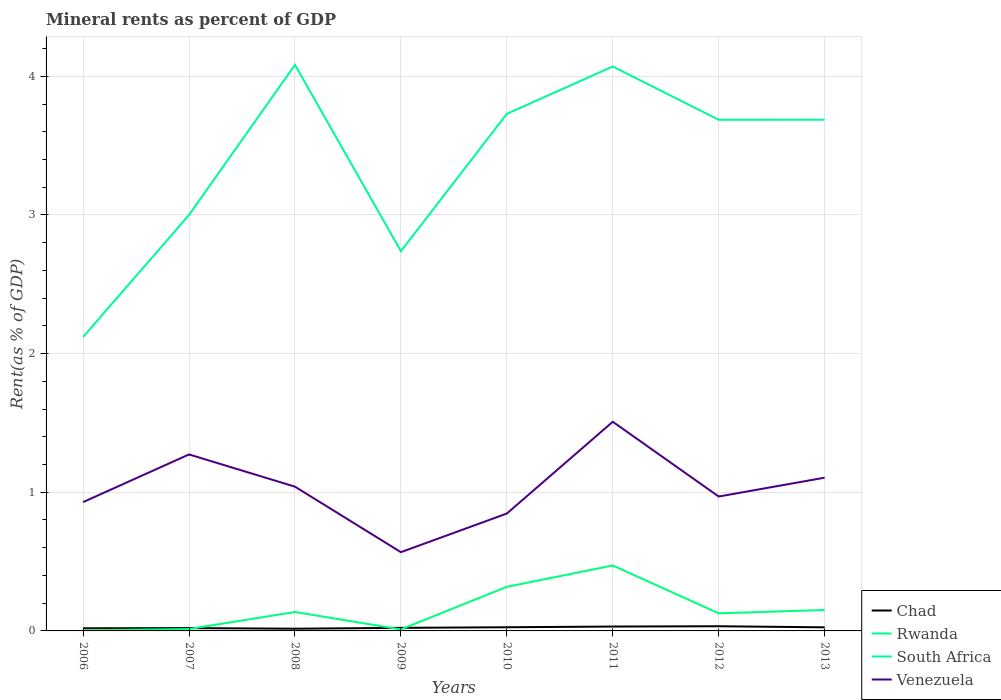Does the line corresponding to Rwanda intersect with the line corresponding to Chad?
Provide a short and direct response. Yes. Across all years, what is the maximum mineral rent in South Africa?
Offer a terse response. 2.12. What is the total mineral rent in Rwanda in the graph?
Ensure brevity in your answer.  -0.12. What is the difference between the highest and the second highest mineral rent in Chad?
Make the answer very short. 0.02. How many lines are there?
Give a very brief answer. 4. How many years are there in the graph?
Make the answer very short. 8. Are the values on the major ticks of Y-axis written in scientific E-notation?
Your response must be concise. No. What is the title of the graph?
Your answer should be very brief. Mineral rents as percent of GDP. What is the label or title of the X-axis?
Offer a terse response. Years. What is the label or title of the Y-axis?
Provide a short and direct response. Rent(as % of GDP). What is the Rent(as % of GDP) in Chad in 2006?
Provide a succinct answer. 0.02. What is the Rent(as % of GDP) of Rwanda in 2006?
Provide a succinct answer. 0. What is the Rent(as % of GDP) in South Africa in 2006?
Your answer should be compact. 2.12. What is the Rent(as % of GDP) of Venezuela in 2006?
Make the answer very short. 0.93. What is the Rent(as % of GDP) in Chad in 2007?
Keep it short and to the point. 0.02. What is the Rent(as % of GDP) in Rwanda in 2007?
Offer a terse response. 0.01. What is the Rent(as % of GDP) in South Africa in 2007?
Ensure brevity in your answer.  3. What is the Rent(as % of GDP) in Venezuela in 2007?
Keep it short and to the point. 1.27. What is the Rent(as % of GDP) of Chad in 2008?
Your response must be concise. 0.02. What is the Rent(as % of GDP) in Rwanda in 2008?
Offer a very short reply. 0.14. What is the Rent(as % of GDP) in South Africa in 2008?
Provide a succinct answer. 4.08. What is the Rent(as % of GDP) in Venezuela in 2008?
Your answer should be compact. 1.04. What is the Rent(as % of GDP) in Chad in 2009?
Keep it short and to the point. 0.02. What is the Rent(as % of GDP) of Rwanda in 2009?
Offer a very short reply. 0.01. What is the Rent(as % of GDP) of South Africa in 2009?
Offer a very short reply. 2.74. What is the Rent(as % of GDP) in Venezuela in 2009?
Offer a terse response. 0.57. What is the Rent(as % of GDP) in Chad in 2010?
Provide a short and direct response. 0.03. What is the Rent(as % of GDP) in Rwanda in 2010?
Your answer should be very brief. 0.32. What is the Rent(as % of GDP) of South Africa in 2010?
Your answer should be very brief. 3.73. What is the Rent(as % of GDP) in Venezuela in 2010?
Make the answer very short. 0.85. What is the Rent(as % of GDP) of Chad in 2011?
Your answer should be compact. 0.03. What is the Rent(as % of GDP) in Rwanda in 2011?
Your answer should be compact. 0.47. What is the Rent(as % of GDP) of South Africa in 2011?
Your response must be concise. 4.07. What is the Rent(as % of GDP) in Venezuela in 2011?
Your response must be concise. 1.51. What is the Rent(as % of GDP) of Chad in 2012?
Offer a terse response. 0.03. What is the Rent(as % of GDP) in Rwanda in 2012?
Provide a short and direct response. 0.13. What is the Rent(as % of GDP) of South Africa in 2012?
Your response must be concise. 3.69. What is the Rent(as % of GDP) in Venezuela in 2012?
Provide a succinct answer. 0.97. What is the Rent(as % of GDP) of Chad in 2013?
Your response must be concise. 0.03. What is the Rent(as % of GDP) in Rwanda in 2013?
Your answer should be very brief. 0.15. What is the Rent(as % of GDP) in South Africa in 2013?
Make the answer very short. 3.69. What is the Rent(as % of GDP) of Venezuela in 2013?
Offer a very short reply. 1.11. Across all years, what is the maximum Rent(as % of GDP) of Chad?
Your answer should be very brief. 0.03. Across all years, what is the maximum Rent(as % of GDP) in Rwanda?
Make the answer very short. 0.47. Across all years, what is the maximum Rent(as % of GDP) in South Africa?
Offer a terse response. 4.08. Across all years, what is the maximum Rent(as % of GDP) in Venezuela?
Your answer should be compact. 1.51. Across all years, what is the minimum Rent(as % of GDP) in Chad?
Keep it short and to the point. 0.02. Across all years, what is the minimum Rent(as % of GDP) of Rwanda?
Provide a succinct answer. 0. Across all years, what is the minimum Rent(as % of GDP) of South Africa?
Offer a very short reply. 2.12. Across all years, what is the minimum Rent(as % of GDP) of Venezuela?
Provide a short and direct response. 0.57. What is the total Rent(as % of GDP) in Chad in the graph?
Your answer should be very brief. 0.2. What is the total Rent(as % of GDP) of Rwanda in the graph?
Your answer should be very brief. 1.23. What is the total Rent(as % of GDP) in South Africa in the graph?
Ensure brevity in your answer.  27.11. What is the total Rent(as % of GDP) of Venezuela in the graph?
Provide a succinct answer. 8.24. What is the difference between the Rent(as % of GDP) of Chad in 2006 and that in 2007?
Your response must be concise. -0. What is the difference between the Rent(as % of GDP) of Rwanda in 2006 and that in 2007?
Provide a succinct answer. -0.01. What is the difference between the Rent(as % of GDP) in South Africa in 2006 and that in 2007?
Give a very brief answer. -0.88. What is the difference between the Rent(as % of GDP) in Venezuela in 2006 and that in 2007?
Provide a short and direct response. -0.34. What is the difference between the Rent(as % of GDP) in Chad in 2006 and that in 2008?
Keep it short and to the point. 0. What is the difference between the Rent(as % of GDP) in Rwanda in 2006 and that in 2008?
Your response must be concise. -0.13. What is the difference between the Rent(as % of GDP) in South Africa in 2006 and that in 2008?
Offer a terse response. -1.96. What is the difference between the Rent(as % of GDP) of Venezuela in 2006 and that in 2008?
Provide a short and direct response. -0.11. What is the difference between the Rent(as % of GDP) of Chad in 2006 and that in 2009?
Your response must be concise. -0. What is the difference between the Rent(as % of GDP) in Rwanda in 2006 and that in 2009?
Your answer should be compact. -0.01. What is the difference between the Rent(as % of GDP) of South Africa in 2006 and that in 2009?
Make the answer very short. -0.62. What is the difference between the Rent(as % of GDP) of Venezuela in 2006 and that in 2009?
Your response must be concise. 0.36. What is the difference between the Rent(as % of GDP) in Chad in 2006 and that in 2010?
Offer a very short reply. -0.01. What is the difference between the Rent(as % of GDP) of Rwanda in 2006 and that in 2010?
Offer a very short reply. -0.31. What is the difference between the Rent(as % of GDP) in South Africa in 2006 and that in 2010?
Make the answer very short. -1.61. What is the difference between the Rent(as % of GDP) in Venezuela in 2006 and that in 2010?
Your answer should be very brief. 0.08. What is the difference between the Rent(as % of GDP) of Chad in 2006 and that in 2011?
Keep it short and to the point. -0.01. What is the difference between the Rent(as % of GDP) of Rwanda in 2006 and that in 2011?
Provide a succinct answer. -0.47. What is the difference between the Rent(as % of GDP) in South Africa in 2006 and that in 2011?
Your answer should be compact. -1.95. What is the difference between the Rent(as % of GDP) in Venezuela in 2006 and that in 2011?
Ensure brevity in your answer.  -0.58. What is the difference between the Rent(as % of GDP) in Chad in 2006 and that in 2012?
Provide a succinct answer. -0.01. What is the difference between the Rent(as % of GDP) of Rwanda in 2006 and that in 2012?
Ensure brevity in your answer.  -0.12. What is the difference between the Rent(as % of GDP) in South Africa in 2006 and that in 2012?
Your answer should be compact. -1.57. What is the difference between the Rent(as % of GDP) in Venezuela in 2006 and that in 2012?
Offer a very short reply. -0.04. What is the difference between the Rent(as % of GDP) in Chad in 2006 and that in 2013?
Provide a succinct answer. -0.01. What is the difference between the Rent(as % of GDP) in Rwanda in 2006 and that in 2013?
Your answer should be compact. -0.15. What is the difference between the Rent(as % of GDP) of South Africa in 2006 and that in 2013?
Your answer should be compact. -1.57. What is the difference between the Rent(as % of GDP) of Venezuela in 2006 and that in 2013?
Offer a terse response. -0.18. What is the difference between the Rent(as % of GDP) in Chad in 2007 and that in 2008?
Ensure brevity in your answer.  0. What is the difference between the Rent(as % of GDP) of Rwanda in 2007 and that in 2008?
Your response must be concise. -0.12. What is the difference between the Rent(as % of GDP) in South Africa in 2007 and that in 2008?
Your response must be concise. -1.08. What is the difference between the Rent(as % of GDP) in Venezuela in 2007 and that in 2008?
Offer a very short reply. 0.23. What is the difference between the Rent(as % of GDP) in Chad in 2007 and that in 2009?
Your response must be concise. -0. What is the difference between the Rent(as % of GDP) in Rwanda in 2007 and that in 2009?
Make the answer very short. 0. What is the difference between the Rent(as % of GDP) in South Africa in 2007 and that in 2009?
Your answer should be very brief. 0.26. What is the difference between the Rent(as % of GDP) in Venezuela in 2007 and that in 2009?
Provide a short and direct response. 0.7. What is the difference between the Rent(as % of GDP) in Chad in 2007 and that in 2010?
Make the answer very short. -0.01. What is the difference between the Rent(as % of GDP) of Rwanda in 2007 and that in 2010?
Offer a terse response. -0.3. What is the difference between the Rent(as % of GDP) in South Africa in 2007 and that in 2010?
Offer a very short reply. -0.73. What is the difference between the Rent(as % of GDP) in Venezuela in 2007 and that in 2010?
Your answer should be compact. 0.43. What is the difference between the Rent(as % of GDP) in Chad in 2007 and that in 2011?
Provide a succinct answer. -0.01. What is the difference between the Rent(as % of GDP) in Rwanda in 2007 and that in 2011?
Your answer should be compact. -0.46. What is the difference between the Rent(as % of GDP) of South Africa in 2007 and that in 2011?
Keep it short and to the point. -1.07. What is the difference between the Rent(as % of GDP) of Venezuela in 2007 and that in 2011?
Your response must be concise. -0.24. What is the difference between the Rent(as % of GDP) of Chad in 2007 and that in 2012?
Your response must be concise. -0.01. What is the difference between the Rent(as % of GDP) in Rwanda in 2007 and that in 2012?
Your response must be concise. -0.11. What is the difference between the Rent(as % of GDP) in South Africa in 2007 and that in 2012?
Your response must be concise. -0.69. What is the difference between the Rent(as % of GDP) in Venezuela in 2007 and that in 2012?
Keep it short and to the point. 0.3. What is the difference between the Rent(as % of GDP) of Chad in 2007 and that in 2013?
Offer a very short reply. -0.01. What is the difference between the Rent(as % of GDP) of Rwanda in 2007 and that in 2013?
Provide a short and direct response. -0.14. What is the difference between the Rent(as % of GDP) in South Africa in 2007 and that in 2013?
Your response must be concise. -0.69. What is the difference between the Rent(as % of GDP) in Venezuela in 2007 and that in 2013?
Offer a very short reply. 0.17. What is the difference between the Rent(as % of GDP) of Chad in 2008 and that in 2009?
Provide a succinct answer. -0.01. What is the difference between the Rent(as % of GDP) in Rwanda in 2008 and that in 2009?
Offer a terse response. 0.13. What is the difference between the Rent(as % of GDP) in South Africa in 2008 and that in 2009?
Keep it short and to the point. 1.34. What is the difference between the Rent(as % of GDP) in Venezuela in 2008 and that in 2009?
Provide a succinct answer. 0.47. What is the difference between the Rent(as % of GDP) of Chad in 2008 and that in 2010?
Your response must be concise. -0.01. What is the difference between the Rent(as % of GDP) of Rwanda in 2008 and that in 2010?
Provide a succinct answer. -0.18. What is the difference between the Rent(as % of GDP) in South Africa in 2008 and that in 2010?
Provide a short and direct response. 0.35. What is the difference between the Rent(as % of GDP) of Venezuela in 2008 and that in 2010?
Ensure brevity in your answer.  0.19. What is the difference between the Rent(as % of GDP) in Chad in 2008 and that in 2011?
Your answer should be compact. -0.02. What is the difference between the Rent(as % of GDP) of Rwanda in 2008 and that in 2011?
Your answer should be very brief. -0.34. What is the difference between the Rent(as % of GDP) of South Africa in 2008 and that in 2011?
Provide a short and direct response. 0.01. What is the difference between the Rent(as % of GDP) of Venezuela in 2008 and that in 2011?
Offer a terse response. -0.47. What is the difference between the Rent(as % of GDP) of Chad in 2008 and that in 2012?
Your answer should be compact. -0.02. What is the difference between the Rent(as % of GDP) in Rwanda in 2008 and that in 2012?
Make the answer very short. 0.01. What is the difference between the Rent(as % of GDP) of South Africa in 2008 and that in 2012?
Provide a succinct answer. 0.4. What is the difference between the Rent(as % of GDP) in Venezuela in 2008 and that in 2012?
Provide a short and direct response. 0.07. What is the difference between the Rent(as % of GDP) in Chad in 2008 and that in 2013?
Make the answer very short. -0.01. What is the difference between the Rent(as % of GDP) of Rwanda in 2008 and that in 2013?
Your answer should be compact. -0.01. What is the difference between the Rent(as % of GDP) in South Africa in 2008 and that in 2013?
Ensure brevity in your answer.  0.4. What is the difference between the Rent(as % of GDP) of Venezuela in 2008 and that in 2013?
Your answer should be compact. -0.06. What is the difference between the Rent(as % of GDP) of Chad in 2009 and that in 2010?
Make the answer very short. -0. What is the difference between the Rent(as % of GDP) of Rwanda in 2009 and that in 2010?
Your response must be concise. -0.31. What is the difference between the Rent(as % of GDP) in South Africa in 2009 and that in 2010?
Offer a very short reply. -0.99. What is the difference between the Rent(as % of GDP) of Venezuela in 2009 and that in 2010?
Ensure brevity in your answer.  -0.28. What is the difference between the Rent(as % of GDP) of Chad in 2009 and that in 2011?
Provide a succinct answer. -0.01. What is the difference between the Rent(as % of GDP) in Rwanda in 2009 and that in 2011?
Your answer should be compact. -0.46. What is the difference between the Rent(as % of GDP) of South Africa in 2009 and that in 2011?
Make the answer very short. -1.33. What is the difference between the Rent(as % of GDP) of Venezuela in 2009 and that in 2011?
Keep it short and to the point. -0.94. What is the difference between the Rent(as % of GDP) in Chad in 2009 and that in 2012?
Your answer should be very brief. -0.01. What is the difference between the Rent(as % of GDP) in Rwanda in 2009 and that in 2012?
Give a very brief answer. -0.12. What is the difference between the Rent(as % of GDP) of South Africa in 2009 and that in 2012?
Give a very brief answer. -0.95. What is the difference between the Rent(as % of GDP) in Venezuela in 2009 and that in 2012?
Offer a terse response. -0.4. What is the difference between the Rent(as % of GDP) in Chad in 2009 and that in 2013?
Your response must be concise. -0. What is the difference between the Rent(as % of GDP) of Rwanda in 2009 and that in 2013?
Keep it short and to the point. -0.14. What is the difference between the Rent(as % of GDP) of South Africa in 2009 and that in 2013?
Your answer should be very brief. -0.95. What is the difference between the Rent(as % of GDP) of Venezuela in 2009 and that in 2013?
Make the answer very short. -0.54. What is the difference between the Rent(as % of GDP) of Chad in 2010 and that in 2011?
Ensure brevity in your answer.  -0.01. What is the difference between the Rent(as % of GDP) of Rwanda in 2010 and that in 2011?
Your response must be concise. -0.15. What is the difference between the Rent(as % of GDP) in South Africa in 2010 and that in 2011?
Offer a very short reply. -0.34. What is the difference between the Rent(as % of GDP) in Venezuela in 2010 and that in 2011?
Keep it short and to the point. -0.66. What is the difference between the Rent(as % of GDP) of Chad in 2010 and that in 2012?
Give a very brief answer. -0.01. What is the difference between the Rent(as % of GDP) in Rwanda in 2010 and that in 2012?
Your answer should be compact. 0.19. What is the difference between the Rent(as % of GDP) in South Africa in 2010 and that in 2012?
Your answer should be very brief. 0.04. What is the difference between the Rent(as % of GDP) in Venezuela in 2010 and that in 2012?
Your answer should be compact. -0.12. What is the difference between the Rent(as % of GDP) in Chad in 2010 and that in 2013?
Keep it short and to the point. 0. What is the difference between the Rent(as % of GDP) of Rwanda in 2010 and that in 2013?
Offer a terse response. 0.17. What is the difference between the Rent(as % of GDP) of South Africa in 2010 and that in 2013?
Your response must be concise. 0.04. What is the difference between the Rent(as % of GDP) in Venezuela in 2010 and that in 2013?
Ensure brevity in your answer.  -0.26. What is the difference between the Rent(as % of GDP) in Chad in 2011 and that in 2012?
Offer a very short reply. -0. What is the difference between the Rent(as % of GDP) in Rwanda in 2011 and that in 2012?
Provide a short and direct response. 0.34. What is the difference between the Rent(as % of GDP) in South Africa in 2011 and that in 2012?
Your answer should be compact. 0.38. What is the difference between the Rent(as % of GDP) in Venezuela in 2011 and that in 2012?
Your answer should be very brief. 0.54. What is the difference between the Rent(as % of GDP) of Chad in 2011 and that in 2013?
Your answer should be very brief. 0.01. What is the difference between the Rent(as % of GDP) in Rwanda in 2011 and that in 2013?
Your answer should be very brief. 0.32. What is the difference between the Rent(as % of GDP) in South Africa in 2011 and that in 2013?
Your answer should be compact. 0.38. What is the difference between the Rent(as % of GDP) in Venezuela in 2011 and that in 2013?
Provide a short and direct response. 0.4. What is the difference between the Rent(as % of GDP) in Chad in 2012 and that in 2013?
Your answer should be very brief. 0.01. What is the difference between the Rent(as % of GDP) in Rwanda in 2012 and that in 2013?
Your response must be concise. -0.02. What is the difference between the Rent(as % of GDP) of South Africa in 2012 and that in 2013?
Give a very brief answer. -0. What is the difference between the Rent(as % of GDP) of Venezuela in 2012 and that in 2013?
Your response must be concise. -0.14. What is the difference between the Rent(as % of GDP) of Chad in 2006 and the Rent(as % of GDP) of Rwanda in 2007?
Your response must be concise. 0.01. What is the difference between the Rent(as % of GDP) in Chad in 2006 and the Rent(as % of GDP) in South Africa in 2007?
Ensure brevity in your answer.  -2.98. What is the difference between the Rent(as % of GDP) in Chad in 2006 and the Rent(as % of GDP) in Venezuela in 2007?
Provide a succinct answer. -1.25. What is the difference between the Rent(as % of GDP) in Rwanda in 2006 and the Rent(as % of GDP) in South Africa in 2007?
Your response must be concise. -3. What is the difference between the Rent(as % of GDP) in Rwanda in 2006 and the Rent(as % of GDP) in Venezuela in 2007?
Provide a succinct answer. -1.27. What is the difference between the Rent(as % of GDP) of South Africa in 2006 and the Rent(as % of GDP) of Venezuela in 2007?
Provide a short and direct response. 0.85. What is the difference between the Rent(as % of GDP) in Chad in 2006 and the Rent(as % of GDP) in Rwanda in 2008?
Offer a terse response. -0.12. What is the difference between the Rent(as % of GDP) of Chad in 2006 and the Rent(as % of GDP) of South Africa in 2008?
Provide a succinct answer. -4.06. What is the difference between the Rent(as % of GDP) of Chad in 2006 and the Rent(as % of GDP) of Venezuela in 2008?
Keep it short and to the point. -1.02. What is the difference between the Rent(as % of GDP) in Rwanda in 2006 and the Rent(as % of GDP) in South Africa in 2008?
Keep it short and to the point. -4.08. What is the difference between the Rent(as % of GDP) in Rwanda in 2006 and the Rent(as % of GDP) in Venezuela in 2008?
Offer a terse response. -1.04. What is the difference between the Rent(as % of GDP) in South Africa in 2006 and the Rent(as % of GDP) in Venezuela in 2008?
Your answer should be compact. 1.08. What is the difference between the Rent(as % of GDP) of Chad in 2006 and the Rent(as % of GDP) of Rwanda in 2009?
Your answer should be very brief. 0.01. What is the difference between the Rent(as % of GDP) in Chad in 2006 and the Rent(as % of GDP) in South Africa in 2009?
Provide a short and direct response. -2.72. What is the difference between the Rent(as % of GDP) in Chad in 2006 and the Rent(as % of GDP) in Venezuela in 2009?
Your response must be concise. -0.55. What is the difference between the Rent(as % of GDP) of Rwanda in 2006 and the Rent(as % of GDP) of South Africa in 2009?
Your response must be concise. -2.73. What is the difference between the Rent(as % of GDP) of Rwanda in 2006 and the Rent(as % of GDP) of Venezuela in 2009?
Provide a succinct answer. -0.56. What is the difference between the Rent(as % of GDP) in South Africa in 2006 and the Rent(as % of GDP) in Venezuela in 2009?
Your answer should be very brief. 1.55. What is the difference between the Rent(as % of GDP) of Chad in 2006 and the Rent(as % of GDP) of Rwanda in 2010?
Offer a very short reply. -0.3. What is the difference between the Rent(as % of GDP) in Chad in 2006 and the Rent(as % of GDP) in South Africa in 2010?
Your answer should be very brief. -3.71. What is the difference between the Rent(as % of GDP) in Chad in 2006 and the Rent(as % of GDP) in Venezuela in 2010?
Your answer should be compact. -0.83. What is the difference between the Rent(as % of GDP) of Rwanda in 2006 and the Rent(as % of GDP) of South Africa in 2010?
Ensure brevity in your answer.  -3.73. What is the difference between the Rent(as % of GDP) of Rwanda in 2006 and the Rent(as % of GDP) of Venezuela in 2010?
Make the answer very short. -0.84. What is the difference between the Rent(as % of GDP) in South Africa in 2006 and the Rent(as % of GDP) in Venezuela in 2010?
Offer a terse response. 1.27. What is the difference between the Rent(as % of GDP) of Chad in 2006 and the Rent(as % of GDP) of Rwanda in 2011?
Ensure brevity in your answer.  -0.45. What is the difference between the Rent(as % of GDP) of Chad in 2006 and the Rent(as % of GDP) of South Africa in 2011?
Provide a short and direct response. -4.05. What is the difference between the Rent(as % of GDP) in Chad in 2006 and the Rent(as % of GDP) in Venezuela in 2011?
Your answer should be compact. -1.49. What is the difference between the Rent(as % of GDP) of Rwanda in 2006 and the Rent(as % of GDP) of South Africa in 2011?
Ensure brevity in your answer.  -4.07. What is the difference between the Rent(as % of GDP) of Rwanda in 2006 and the Rent(as % of GDP) of Venezuela in 2011?
Ensure brevity in your answer.  -1.5. What is the difference between the Rent(as % of GDP) of South Africa in 2006 and the Rent(as % of GDP) of Venezuela in 2011?
Your response must be concise. 0.61. What is the difference between the Rent(as % of GDP) of Chad in 2006 and the Rent(as % of GDP) of Rwanda in 2012?
Keep it short and to the point. -0.11. What is the difference between the Rent(as % of GDP) of Chad in 2006 and the Rent(as % of GDP) of South Africa in 2012?
Your answer should be compact. -3.67. What is the difference between the Rent(as % of GDP) of Chad in 2006 and the Rent(as % of GDP) of Venezuela in 2012?
Your response must be concise. -0.95. What is the difference between the Rent(as % of GDP) in Rwanda in 2006 and the Rent(as % of GDP) in South Africa in 2012?
Make the answer very short. -3.68. What is the difference between the Rent(as % of GDP) of Rwanda in 2006 and the Rent(as % of GDP) of Venezuela in 2012?
Keep it short and to the point. -0.97. What is the difference between the Rent(as % of GDP) of South Africa in 2006 and the Rent(as % of GDP) of Venezuela in 2012?
Give a very brief answer. 1.15. What is the difference between the Rent(as % of GDP) in Chad in 2006 and the Rent(as % of GDP) in Rwanda in 2013?
Give a very brief answer. -0.13. What is the difference between the Rent(as % of GDP) of Chad in 2006 and the Rent(as % of GDP) of South Africa in 2013?
Make the answer very short. -3.67. What is the difference between the Rent(as % of GDP) in Chad in 2006 and the Rent(as % of GDP) in Venezuela in 2013?
Offer a terse response. -1.09. What is the difference between the Rent(as % of GDP) in Rwanda in 2006 and the Rent(as % of GDP) in South Africa in 2013?
Your answer should be very brief. -3.68. What is the difference between the Rent(as % of GDP) of Rwanda in 2006 and the Rent(as % of GDP) of Venezuela in 2013?
Your answer should be compact. -1.1. What is the difference between the Rent(as % of GDP) in South Africa in 2006 and the Rent(as % of GDP) in Venezuela in 2013?
Your answer should be compact. 1.01. What is the difference between the Rent(as % of GDP) in Chad in 2007 and the Rent(as % of GDP) in Rwanda in 2008?
Make the answer very short. -0.12. What is the difference between the Rent(as % of GDP) of Chad in 2007 and the Rent(as % of GDP) of South Africa in 2008?
Your answer should be very brief. -4.06. What is the difference between the Rent(as % of GDP) in Chad in 2007 and the Rent(as % of GDP) in Venezuela in 2008?
Provide a succinct answer. -1.02. What is the difference between the Rent(as % of GDP) of Rwanda in 2007 and the Rent(as % of GDP) of South Africa in 2008?
Offer a very short reply. -4.07. What is the difference between the Rent(as % of GDP) of Rwanda in 2007 and the Rent(as % of GDP) of Venezuela in 2008?
Provide a succinct answer. -1.03. What is the difference between the Rent(as % of GDP) in South Africa in 2007 and the Rent(as % of GDP) in Venezuela in 2008?
Offer a very short reply. 1.96. What is the difference between the Rent(as % of GDP) in Chad in 2007 and the Rent(as % of GDP) in Rwanda in 2009?
Offer a terse response. 0.01. What is the difference between the Rent(as % of GDP) in Chad in 2007 and the Rent(as % of GDP) in South Africa in 2009?
Your response must be concise. -2.72. What is the difference between the Rent(as % of GDP) in Chad in 2007 and the Rent(as % of GDP) in Venezuela in 2009?
Offer a very short reply. -0.55. What is the difference between the Rent(as % of GDP) in Rwanda in 2007 and the Rent(as % of GDP) in South Africa in 2009?
Keep it short and to the point. -2.73. What is the difference between the Rent(as % of GDP) of Rwanda in 2007 and the Rent(as % of GDP) of Venezuela in 2009?
Your answer should be compact. -0.55. What is the difference between the Rent(as % of GDP) of South Africa in 2007 and the Rent(as % of GDP) of Venezuela in 2009?
Ensure brevity in your answer.  2.43. What is the difference between the Rent(as % of GDP) of Chad in 2007 and the Rent(as % of GDP) of Rwanda in 2010?
Provide a succinct answer. -0.3. What is the difference between the Rent(as % of GDP) in Chad in 2007 and the Rent(as % of GDP) in South Africa in 2010?
Provide a succinct answer. -3.71. What is the difference between the Rent(as % of GDP) of Chad in 2007 and the Rent(as % of GDP) of Venezuela in 2010?
Offer a terse response. -0.83. What is the difference between the Rent(as % of GDP) of Rwanda in 2007 and the Rent(as % of GDP) of South Africa in 2010?
Provide a short and direct response. -3.72. What is the difference between the Rent(as % of GDP) in Rwanda in 2007 and the Rent(as % of GDP) in Venezuela in 2010?
Keep it short and to the point. -0.83. What is the difference between the Rent(as % of GDP) in South Africa in 2007 and the Rent(as % of GDP) in Venezuela in 2010?
Offer a terse response. 2.15. What is the difference between the Rent(as % of GDP) in Chad in 2007 and the Rent(as % of GDP) in Rwanda in 2011?
Your answer should be compact. -0.45. What is the difference between the Rent(as % of GDP) of Chad in 2007 and the Rent(as % of GDP) of South Africa in 2011?
Offer a very short reply. -4.05. What is the difference between the Rent(as % of GDP) in Chad in 2007 and the Rent(as % of GDP) in Venezuela in 2011?
Give a very brief answer. -1.49. What is the difference between the Rent(as % of GDP) in Rwanda in 2007 and the Rent(as % of GDP) in South Africa in 2011?
Your answer should be compact. -4.06. What is the difference between the Rent(as % of GDP) of Rwanda in 2007 and the Rent(as % of GDP) of Venezuela in 2011?
Your answer should be compact. -1.49. What is the difference between the Rent(as % of GDP) in South Africa in 2007 and the Rent(as % of GDP) in Venezuela in 2011?
Your response must be concise. 1.49. What is the difference between the Rent(as % of GDP) of Chad in 2007 and the Rent(as % of GDP) of Rwanda in 2012?
Provide a succinct answer. -0.11. What is the difference between the Rent(as % of GDP) in Chad in 2007 and the Rent(as % of GDP) in South Africa in 2012?
Give a very brief answer. -3.67. What is the difference between the Rent(as % of GDP) in Chad in 2007 and the Rent(as % of GDP) in Venezuela in 2012?
Ensure brevity in your answer.  -0.95. What is the difference between the Rent(as % of GDP) in Rwanda in 2007 and the Rent(as % of GDP) in South Africa in 2012?
Give a very brief answer. -3.67. What is the difference between the Rent(as % of GDP) in Rwanda in 2007 and the Rent(as % of GDP) in Venezuela in 2012?
Offer a terse response. -0.96. What is the difference between the Rent(as % of GDP) in South Africa in 2007 and the Rent(as % of GDP) in Venezuela in 2012?
Your answer should be compact. 2.03. What is the difference between the Rent(as % of GDP) in Chad in 2007 and the Rent(as % of GDP) in Rwanda in 2013?
Ensure brevity in your answer.  -0.13. What is the difference between the Rent(as % of GDP) of Chad in 2007 and the Rent(as % of GDP) of South Africa in 2013?
Your answer should be very brief. -3.67. What is the difference between the Rent(as % of GDP) of Chad in 2007 and the Rent(as % of GDP) of Venezuela in 2013?
Provide a short and direct response. -1.08. What is the difference between the Rent(as % of GDP) of Rwanda in 2007 and the Rent(as % of GDP) of South Africa in 2013?
Your answer should be compact. -3.67. What is the difference between the Rent(as % of GDP) of Rwanda in 2007 and the Rent(as % of GDP) of Venezuela in 2013?
Provide a succinct answer. -1.09. What is the difference between the Rent(as % of GDP) of South Africa in 2007 and the Rent(as % of GDP) of Venezuela in 2013?
Keep it short and to the point. 1.89. What is the difference between the Rent(as % of GDP) of Chad in 2008 and the Rent(as % of GDP) of Rwanda in 2009?
Keep it short and to the point. 0.01. What is the difference between the Rent(as % of GDP) in Chad in 2008 and the Rent(as % of GDP) in South Africa in 2009?
Your response must be concise. -2.72. What is the difference between the Rent(as % of GDP) of Chad in 2008 and the Rent(as % of GDP) of Venezuela in 2009?
Provide a succinct answer. -0.55. What is the difference between the Rent(as % of GDP) in Rwanda in 2008 and the Rent(as % of GDP) in South Africa in 2009?
Provide a succinct answer. -2.6. What is the difference between the Rent(as % of GDP) of Rwanda in 2008 and the Rent(as % of GDP) of Venezuela in 2009?
Give a very brief answer. -0.43. What is the difference between the Rent(as % of GDP) in South Africa in 2008 and the Rent(as % of GDP) in Venezuela in 2009?
Make the answer very short. 3.51. What is the difference between the Rent(as % of GDP) in Chad in 2008 and the Rent(as % of GDP) in Rwanda in 2010?
Keep it short and to the point. -0.3. What is the difference between the Rent(as % of GDP) in Chad in 2008 and the Rent(as % of GDP) in South Africa in 2010?
Your response must be concise. -3.71. What is the difference between the Rent(as % of GDP) in Chad in 2008 and the Rent(as % of GDP) in Venezuela in 2010?
Provide a short and direct response. -0.83. What is the difference between the Rent(as % of GDP) of Rwanda in 2008 and the Rent(as % of GDP) of South Africa in 2010?
Your answer should be compact. -3.59. What is the difference between the Rent(as % of GDP) in Rwanda in 2008 and the Rent(as % of GDP) in Venezuela in 2010?
Provide a succinct answer. -0.71. What is the difference between the Rent(as % of GDP) in South Africa in 2008 and the Rent(as % of GDP) in Venezuela in 2010?
Offer a terse response. 3.24. What is the difference between the Rent(as % of GDP) of Chad in 2008 and the Rent(as % of GDP) of Rwanda in 2011?
Offer a very short reply. -0.46. What is the difference between the Rent(as % of GDP) of Chad in 2008 and the Rent(as % of GDP) of South Africa in 2011?
Your answer should be very brief. -4.05. What is the difference between the Rent(as % of GDP) of Chad in 2008 and the Rent(as % of GDP) of Venezuela in 2011?
Give a very brief answer. -1.49. What is the difference between the Rent(as % of GDP) of Rwanda in 2008 and the Rent(as % of GDP) of South Africa in 2011?
Make the answer very short. -3.93. What is the difference between the Rent(as % of GDP) of Rwanda in 2008 and the Rent(as % of GDP) of Venezuela in 2011?
Your answer should be compact. -1.37. What is the difference between the Rent(as % of GDP) of South Africa in 2008 and the Rent(as % of GDP) of Venezuela in 2011?
Provide a succinct answer. 2.57. What is the difference between the Rent(as % of GDP) in Chad in 2008 and the Rent(as % of GDP) in Rwanda in 2012?
Ensure brevity in your answer.  -0.11. What is the difference between the Rent(as % of GDP) in Chad in 2008 and the Rent(as % of GDP) in South Africa in 2012?
Give a very brief answer. -3.67. What is the difference between the Rent(as % of GDP) of Chad in 2008 and the Rent(as % of GDP) of Venezuela in 2012?
Your answer should be compact. -0.95. What is the difference between the Rent(as % of GDP) of Rwanda in 2008 and the Rent(as % of GDP) of South Africa in 2012?
Provide a succinct answer. -3.55. What is the difference between the Rent(as % of GDP) in Rwanda in 2008 and the Rent(as % of GDP) in Venezuela in 2012?
Your response must be concise. -0.83. What is the difference between the Rent(as % of GDP) in South Africa in 2008 and the Rent(as % of GDP) in Venezuela in 2012?
Provide a short and direct response. 3.11. What is the difference between the Rent(as % of GDP) of Chad in 2008 and the Rent(as % of GDP) of Rwanda in 2013?
Keep it short and to the point. -0.13. What is the difference between the Rent(as % of GDP) in Chad in 2008 and the Rent(as % of GDP) in South Africa in 2013?
Provide a short and direct response. -3.67. What is the difference between the Rent(as % of GDP) of Chad in 2008 and the Rent(as % of GDP) of Venezuela in 2013?
Offer a terse response. -1.09. What is the difference between the Rent(as % of GDP) of Rwanda in 2008 and the Rent(as % of GDP) of South Africa in 2013?
Provide a short and direct response. -3.55. What is the difference between the Rent(as % of GDP) of Rwanda in 2008 and the Rent(as % of GDP) of Venezuela in 2013?
Provide a short and direct response. -0.97. What is the difference between the Rent(as % of GDP) of South Africa in 2008 and the Rent(as % of GDP) of Venezuela in 2013?
Provide a short and direct response. 2.98. What is the difference between the Rent(as % of GDP) in Chad in 2009 and the Rent(as % of GDP) in Rwanda in 2010?
Ensure brevity in your answer.  -0.3. What is the difference between the Rent(as % of GDP) of Chad in 2009 and the Rent(as % of GDP) of South Africa in 2010?
Your response must be concise. -3.71. What is the difference between the Rent(as % of GDP) of Chad in 2009 and the Rent(as % of GDP) of Venezuela in 2010?
Your response must be concise. -0.82. What is the difference between the Rent(as % of GDP) in Rwanda in 2009 and the Rent(as % of GDP) in South Africa in 2010?
Ensure brevity in your answer.  -3.72. What is the difference between the Rent(as % of GDP) of Rwanda in 2009 and the Rent(as % of GDP) of Venezuela in 2010?
Give a very brief answer. -0.84. What is the difference between the Rent(as % of GDP) in South Africa in 2009 and the Rent(as % of GDP) in Venezuela in 2010?
Provide a succinct answer. 1.89. What is the difference between the Rent(as % of GDP) of Chad in 2009 and the Rent(as % of GDP) of Rwanda in 2011?
Keep it short and to the point. -0.45. What is the difference between the Rent(as % of GDP) in Chad in 2009 and the Rent(as % of GDP) in South Africa in 2011?
Provide a short and direct response. -4.05. What is the difference between the Rent(as % of GDP) of Chad in 2009 and the Rent(as % of GDP) of Venezuela in 2011?
Provide a succinct answer. -1.49. What is the difference between the Rent(as % of GDP) in Rwanda in 2009 and the Rent(as % of GDP) in South Africa in 2011?
Your answer should be very brief. -4.06. What is the difference between the Rent(as % of GDP) in Rwanda in 2009 and the Rent(as % of GDP) in Venezuela in 2011?
Provide a succinct answer. -1.5. What is the difference between the Rent(as % of GDP) in South Africa in 2009 and the Rent(as % of GDP) in Venezuela in 2011?
Keep it short and to the point. 1.23. What is the difference between the Rent(as % of GDP) in Chad in 2009 and the Rent(as % of GDP) in Rwanda in 2012?
Make the answer very short. -0.1. What is the difference between the Rent(as % of GDP) of Chad in 2009 and the Rent(as % of GDP) of South Africa in 2012?
Offer a very short reply. -3.66. What is the difference between the Rent(as % of GDP) of Chad in 2009 and the Rent(as % of GDP) of Venezuela in 2012?
Ensure brevity in your answer.  -0.95. What is the difference between the Rent(as % of GDP) of Rwanda in 2009 and the Rent(as % of GDP) of South Africa in 2012?
Your answer should be compact. -3.68. What is the difference between the Rent(as % of GDP) of Rwanda in 2009 and the Rent(as % of GDP) of Venezuela in 2012?
Offer a terse response. -0.96. What is the difference between the Rent(as % of GDP) of South Africa in 2009 and the Rent(as % of GDP) of Venezuela in 2012?
Keep it short and to the point. 1.77. What is the difference between the Rent(as % of GDP) in Chad in 2009 and the Rent(as % of GDP) in Rwanda in 2013?
Your response must be concise. -0.13. What is the difference between the Rent(as % of GDP) of Chad in 2009 and the Rent(as % of GDP) of South Africa in 2013?
Your answer should be compact. -3.66. What is the difference between the Rent(as % of GDP) in Chad in 2009 and the Rent(as % of GDP) in Venezuela in 2013?
Provide a succinct answer. -1.08. What is the difference between the Rent(as % of GDP) in Rwanda in 2009 and the Rent(as % of GDP) in South Africa in 2013?
Your answer should be very brief. -3.68. What is the difference between the Rent(as % of GDP) of Rwanda in 2009 and the Rent(as % of GDP) of Venezuela in 2013?
Offer a very short reply. -1.09. What is the difference between the Rent(as % of GDP) of South Africa in 2009 and the Rent(as % of GDP) of Venezuela in 2013?
Keep it short and to the point. 1.63. What is the difference between the Rent(as % of GDP) of Chad in 2010 and the Rent(as % of GDP) of Rwanda in 2011?
Offer a terse response. -0.45. What is the difference between the Rent(as % of GDP) of Chad in 2010 and the Rent(as % of GDP) of South Africa in 2011?
Your answer should be compact. -4.04. What is the difference between the Rent(as % of GDP) of Chad in 2010 and the Rent(as % of GDP) of Venezuela in 2011?
Make the answer very short. -1.48. What is the difference between the Rent(as % of GDP) in Rwanda in 2010 and the Rent(as % of GDP) in South Africa in 2011?
Keep it short and to the point. -3.75. What is the difference between the Rent(as % of GDP) of Rwanda in 2010 and the Rent(as % of GDP) of Venezuela in 2011?
Give a very brief answer. -1.19. What is the difference between the Rent(as % of GDP) in South Africa in 2010 and the Rent(as % of GDP) in Venezuela in 2011?
Your answer should be compact. 2.22. What is the difference between the Rent(as % of GDP) in Chad in 2010 and the Rent(as % of GDP) in Rwanda in 2012?
Offer a very short reply. -0.1. What is the difference between the Rent(as % of GDP) of Chad in 2010 and the Rent(as % of GDP) of South Africa in 2012?
Make the answer very short. -3.66. What is the difference between the Rent(as % of GDP) of Chad in 2010 and the Rent(as % of GDP) of Venezuela in 2012?
Provide a short and direct response. -0.94. What is the difference between the Rent(as % of GDP) of Rwanda in 2010 and the Rent(as % of GDP) of South Africa in 2012?
Give a very brief answer. -3.37. What is the difference between the Rent(as % of GDP) of Rwanda in 2010 and the Rent(as % of GDP) of Venezuela in 2012?
Your response must be concise. -0.65. What is the difference between the Rent(as % of GDP) in South Africa in 2010 and the Rent(as % of GDP) in Venezuela in 2012?
Provide a short and direct response. 2.76. What is the difference between the Rent(as % of GDP) in Chad in 2010 and the Rent(as % of GDP) in Rwanda in 2013?
Make the answer very short. -0.12. What is the difference between the Rent(as % of GDP) in Chad in 2010 and the Rent(as % of GDP) in South Africa in 2013?
Provide a succinct answer. -3.66. What is the difference between the Rent(as % of GDP) of Chad in 2010 and the Rent(as % of GDP) of Venezuela in 2013?
Provide a succinct answer. -1.08. What is the difference between the Rent(as % of GDP) in Rwanda in 2010 and the Rent(as % of GDP) in South Africa in 2013?
Ensure brevity in your answer.  -3.37. What is the difference between the Rent(as % of GDP) of Rwanda in 2010 and the Rent(as % of GDP) of Venezuela in 2013?
Ensure brevity in your answer.  -0.79. What is the difference between the Rent(as % of GDP) of South Africa in 2010 and the Rent(as % of GDP) of Venezuela in 2013?
Give a very brief answer. 2.62. What is the difference between the Rent(as % of GDP) in Chad in 2011 and the Rent(as % of GDP) in Rwanda in 2012?
Provide a short and direct response. -0.1. What is the difference between the Rent(as % of GDP) in Chad in 2011 and the Rent(as % of GDP) in South Africa in 2012?
Give a very brief answer. -3.65. What is the difference between the Rent(as % of GDP) in Chad in 2011 and the Rent(as % of GDP) in Venezuela in 2012?
Provide a short and direct response. -0.94. What is the difference between the Rent(as % of GDP) in Rwanda in 2011 and the Rent(as % of GDP) in South Africa in 2012?
Offer a very short reply. -3.21. What is the difference between the Rent(as % of GDP) in Rwanda in 2011 and the Rent(as % of GDP) in Venezuela in 2012?
Your response must be concise. -0.5. What is the difference between the Rent(as % of GDP) of South Africa in 2011 and the Rent(as % of GDP) of Venezuela in 2012?
Offer a terse response. 3.1. What is the difference between the Rent(as % of GDP) of Chad in 2011 and the Rent(as % of GDP) of Rwanda in 2013?
Provide a succinct answer. -0.12. What is the difference between the Rent(as % of GDP) in Chad in 2011 and the Rent(as % of GDP) in South Africa in 2013?
Your answer should be very brief. -3.66. What is the difference between the Rent(as % of GDP) of Chad in 2011 and the Rent(as % of GDP) of Venezuela in 2013?
Make the answer very short. -1.07. What is the difference between the Rent(as % of GDP) in Rwanda in 2011 and the Rent(as % of GDP) in South Africa in 2013?
Make the answer very short. -3.21. What is the difference between the Rent(as % of GDP) in Rwanda in 2011 and the Rent(as % of GDP) in Venezuela in 2013?
Make the answer very short. -0.63. What is the difference between the Rent(as % of GDP) in South Africa in 2011 and the Rent(as % of GDP) in Venezuela in 2013?
Make the answer very short. 2.97. What is the difference between the Rent(as % of GDP) of Chad in 2012 and the Rent(as % of GDP) of Rwanda in 2013?
Your answer should be compact. -0.12. What is the difference between the Rent(as % of GDP) in Chad in 2012 and the Rent(as % of GDP) in South Africa in 2013?
Provide a succinct answer. -3.65. What is the difference between the Rent(as % of GDP) in Chad in 2012 and the Rent(as % of GDP) in Venezuela in 2013?
Provide a short and direct response. -1.07. What is the difference between the Rent(as % of GDP) in Rwanda in 2012 and the Rent(as % of GDP) in South Africa in 2013?
Provide a short and direct response. -3.56. What is the difference between the Rent(as % of GDP) in Rwanda in 2012 and the Rent(as % of GDP) in Venezuela in 2013?
Offer a terse response. -0.98. What is the difference between the Rent(as % of GDP) in South Africa in 2012 and the Rent(as % of GDP) in Venezuela in 2013?
Provide a succinct answer. 2.58. What is the average Rent(as % of GDP) of Chad per year?
Provide a succinct answer. 0.02. What is the average Rent(as % of GDP) in Rwanda per year?
Offer a terse response. 0.15. What is the average Rent(as % of GDP) of South Africa per year?
Keep it short and to the point. 3.39. In the year 2006, what is the difference between the Rent(as % of GDP) of Chad and Rent(as % of GDP) of Rwanda?
Provide a short and direct response. 0.01. In the year 2006, what is the difference between the Rent(as % of GDP) of Chad and Rent(as % of GDP) of South Africa?
Your answer should be very brief. -2.1. In the year 2006, what is the difference between the Rent(as % of GDP) in Chad and Rent(as % of GDP) in Venezuela?
Give a very brief answer. -0.91. In the year 2006, what is the difference between the Rent(as % of GDP) of Rwanda and Rent(as % of GDP) of South Africa?
Provide a short and direct response. -2.12. In the year 2006, what is the difference between the Rent(as % of GDP) in Rwanda and Rent(as % of GDP) in Venezuela?
Make the answer very short. -0.93. In the year 2006, what is the difference between the Rent(as % of GDP) of South Africa and Rent(as % of GDP) of Venezuela?
Your answer should be very brief. 1.19. In the year 2007, what is the difference between the Rent(as % of GDP) of Chad and Rent(as % of GDP) of Rwanda?
Your response must be concise. 0.01. In the year 2007, what is the difference between the Rent(as % of GDP) in Chad and Rent(as % of GDP) in South Africa?
Make the answer very short. -2.98. In the year 2007, what is the difference between the Rent(as % of GDP) in Chad and Rent(as % of GDP) in Venezuela?
Provide a short and direct response. -1.25. In the year 2007, what is the difference between the Rent(as % of GDP) in Rwanda and Rent(as % of GDP) in South Africa?
Provide a short and direct response. -2.99. In the year 2007, what is the difference between the Rent(as % of GDP) in Rwanda and Rent(as % of GDP) in Venezuela?
Offer a terse response. -1.26. In the year 2007, what is the difference between the Rent(as % of GDP) in South Africa and Rent(as % of GDP) in Venezuela?
Your answer should be compact. 1.73. In the year 2008, what is the difference between the Rent(as % of GDP) in Chad and Rent(as % of GDP) in Rwanda?
Keep it short and to the point. -0.12. In the year 2008, what is the difference between the Rent(as % of GDP) of Chad and Rent(as % of GDP) of South Africa?
Offer a very short reply. -4.07. In the year 2008, what is the difference between the Rent(as % of GDP) in Chad and Rent(as % of GDP) in Venezuela?
Give a very brief answer. -1.02. In the year 2008, what is the difference between the Rent(as % of GDP) in Rwanda and Rent(as % of GDP) in South Africa?
Provide a succinct answer. -3.95. In the year 2008, what is the difference between the Rent(as % of GDP) in Rwanda and Rent(as % of GDP) in Venezuela?
Give a very brief answer. -0.9. In the year 2008, what is the difference between the Rent(as % of GDP) in South Africa and Rent(as % of GDP) in Venezuela?
Provide a short and direct response. 3.04. In the year 2009, what is the difference between the Rent(as % of GDP) in Chad and Rent(as % of GDP) in Rwanda?
Offer a terse response. 0.01. In the year 2009, what is the difference between the Rent(as % of GDP) in Chad and Rent(as % of GDP) in South Africa?
Your response must be concise. -2.72. In the year 2009, what is the difference between the Rent(as % of GDP) in Chad and Rent(as % of GDP) in Venezuela?
Give a very brief answer. -0.55. In the year 2009, what is the difference between the Rent(as % of GDP) of Rwanda and Rent(as % of GDP) of South Africa?
Your answer should be very brief. -2.73. In the year 2009, what is the difference between the Rent(as % of GDP) of Rwanda and Rent(as % of GDP) of Venezuela?
Your answer should be compact. -0.56. In the year 2009, what is the difference between the Rent(as % of GDP) of South Africa and Rent(as % of GDP) of Venezuela?
Offer a very short reply. 2.17. In the year 2010, what is the difference between the Rent(as % of GDP) in Chad and Rent(as % of GDP) in Rwanda?
Keep it short and to the point. -0.29. In the year 2010, what is the difference between the Rent(as % of GDP) in Chad and Rent(as % of GDP) in South Africa?
Your answer should be very brief. -3.7. In the year 2010, what is the difference between the Rent(as % of GDP) in Chad and Rent(as % of GDP) in Venezuela?
Keep it short and to the point. -0.82. In the year 2010, what is the difference between the Rent(as % of GDP) in Rwanda and Rent(as % of GDP) in South Africa?
Give a very brief answer. -3.41. In the year 2010, what is the difference between the Rent(as % of GDP) of Rwanda and Rent(as % of GDP) of Venezuela?
Your answer should be compact. -0.53. In the year 2010, what is the difference between the Rent(as % of GDP) of South Africa and Rent(as % of GDP) of Venezuela?
Your answer should be compact. 2.88. In the year 2011, what is the difference between the Rent(as % of GDP) in Chad and Rent(as % of GDP) in Rwanda?
Offer a terse response. -0.44. In the year 2011, what is the difference between the Rent(as % of GDP) in Chad and Rent(as % of GDP) in South Africa?
Ensure brevity in your answer.  -4.04. In the year 2011, what is the difference between the Rent(as % of GDP) of Chad and Rent(as % of GDP) of Venezuela?
Make the answer very short. -1.48. In the year 2011, what is the difference between the Rent(as % of GDP) in Rwanda and Rent(as % of GDP) in South Africa?
Your answer should be compact. -3.6. In the year 2011, what is the difference between the Rent(as % of GDP) in Rwanda and Rent(as % of GDP) in Venezuela?
Provide a short and direct response. -1.04. In the year 2011, what is the difference between the Rent(as % of GDP) of South Africa and Rent(as % of GDP) of Venezuela?
Your answer should be very brief. 2.56. In the year 2012, what is the difference between the Rent(as % of GDP) of Chad and Rent(as % of GDP) of Rwanda?
Your answer should be compact. -0.09. In the year 2012, what is the difference between the Rent(as % of GDP) in Chad and Rent(as % of GDP) in South Africa?
Provide a succinct answer. -3.65. In the year 2012, what is the difference between the Rent(as % of GDP) in Chad and Rent(as % of GDP) in Venezuela?
Keep it short and to the point. -0.94. In the year 2012, what is the difference between the Rent(as % of GDP) of Rwanda and Rent(as % of GDP) of South Africa?
Keep it short and to the point. -3.56. In the year 2012, what is the difference between the Rent(as % of GDP) in Rwanda and Rent(as % of GDP) in Venezuela?
Ensure brevity in your answer.  -0.84. In the year 2012, what is the difference between the Rent(as % of GDP) in South Africa and Rent(as % of GDP) in Venezuela?
Your answer should be very brief. 2.72. In the year 2013, what is the difference between the Rent(as % of GDP) of Chad and Rent(as % of GDP) of Rwanda?
Give a very brief answer. -0.12. In the year 2013, what is the difference between the Rent(as % of GDP) of Chad and Rent(as % of GDP) of South Africa?
Offer a terse response. -3.66. In the year 2013, what is the difference between the Rent(as % of GDP) of Chad and Rent(as % of GDP) of Venezuela?
Your answer should be compact. -1.08. In the year 2013, what is the difference between the Rent(as % of GDP) of Rwanda and Rent(as % of GDP) of South Africa?
Ensure brevity in your answer.  -3.54. In the year 2013, what is the difference between the Rent(as % of GDP) in Rwanda and Rent(as % of GDP) in Venezuela?
Ensure brevity in your answer.  -0.95. In the year 2013, what is the difference between the Rent(as % of GDP) of South Africa and Rent(as % of GDP) of Venezuela?
Make the answer very short. 2.58. What is the ratio of the Rent(as % of GDP) of Chad in 2006 to that in 2007?
Offer a very short reply. 0.93. What is the ratio of the Rent(as % of GDP) in Rwanda in 2006 to that in 2007?
Your answer should be very brief. 0.29. What is the ratio of the Rent(as % of GDP) in South Africa in 2006 to that in 2007?
Your response must be concise. 0.71. What is the ratio of the Rent(as % of GDP) of Venezuela in 2006 to that in 2007?
Your answer should be very brief. 0.73. What is the ratio of the Rent(as % of GDP) of Chad in 2006 to that in 2008?
Offer a very short reply. 1.19. What is the ratio of the Rent(as % of GDP) in Rwanda in 2006 to that in 2008?
Your answer should be very brief. 0.03. What is the ratio of the Rent(as % of GDP) in South Africa in 2006 to that in 2008?
Give a very brief answer. 0.52. What is the ratio of the Rent(as % of GDP) in Venezuela in 2006 to that in 2008?
Provide a succinct answer. 0.89. What is the ratio of the Rent(as % of GDP) of Chad in 2006 to that in 2009?
Give a very brief answer. 0.86. What is the ratio of the Rent(as % of GDP) of Rwanda in 2006 to that in 2009?
Provide a succinct answer. 0.37. What is the ratio of the Rent(as % of GDP) of South Africa in 2006 to that in 2009?
Your answer should be very brief. 0.77. What is the ratio of the Rent(as % of GDP) in Venezuela in 2006 to that in 2009?
Your answer should be very brief. 1.64. What is the ratio of the Rent(as % of GDP) of Chad in 2006 to that in 2010?
Your answer should be compact. 0.72. What is the ratio of the Rent(as % of GDP) of Rwanda in 2006 to that in 2010?
Offer a terse response. 0.01. What is the ratio of the Rent(as % of GDP) of South Africa in 2006 to that in 2010?
Ensure brevity in your answer.  0.57. What is the ratio of the Rent(as % of GDP) in Venezuela in 2006 to that in 2010?
Ensure brevity in your answer.  1.1. What is the ratio of the Rent(as % of GDP) in Chad in 2006 to that in 2011?
Your answer should be very brief. 0.6. What is the ratio of the Rent(as % of GDP) in Rwanda in 2006 to that in 2011?
Provide a succinct answer. 0.01. What is the ratio of the Rent(as % of GDP) in South Africa in 2006 to that in 2011?
Ensure brevity in your answer.  0.52. What is the ratio of the Rent(as % of GDP) of Venezuela in 2006 to that in 2011?
Your response must be concise. 0.62. What is the ratio of the Rent(as % of GDP) in Chad in 2006 to that in 2012?
Your answer should be very brief. 0.56. What is the ratio of the Rent(as % of GDP) in Rwanda in 2006 to that in 2012?
Provide a succinct answer. 0.03. What is the ratio of the Rent(as % of GDP) in South Africa in 2006 to that in 2012?
Provide a succinct answer. 0.57. What is the ratio of the Rent(as % of GDP) in Venezuela in 2006 to that in 2012?
Keep it short and to the point. 0.96. What is the ratio of the Rent(as % of GDP) in Chad in 2006 to that in 2013?
Keep it short and to the point. 0.73. What is the ratio of the Rent(as % of GDP) in Rwanda in 2006 to that in 2013?
Provide a short and direct response. 0.03. What is the ratio of the Rent(as % of GDP) of South Africa in 2006 to that in 2013?
Offer a very short reply. 0.57. What is the ratio of the Rent(as % of GDP) of Venezuela in 2006 to that in 2013?
Your response must be concise. 0.84. What is the ratio of the Rent(as % of GDP) of Chad in 2007 to that in 2008?
Keep it short and to the point. 1.28. What is the ratio of the Rent(as % of GDP) of Rwanda in 2007 to that in 2008?
Provide a short and direct response. 0.1. What is the ratio of the Rent(as % of GDP) of South Africa in 2007 to that in 2008?
Offer a very short reply. 0.73. What is the ratio of the Rent(as % of GDP) in Venezuela in 2007 to that in 2008?
Your answer should be very brief. 1.22. What is the ratio of the Rent(as % of GDP) in Chad in 2007 to that in 2009?
Ensure brevity in your answer.  0.92. What is the ratio of the Rent(as % of GDP) in Rwanda in 2007 to that in 2009?
Your response must be concise. 1.26. What is the ratio of the Rent(as % of GDP) in South Africa in 2007 to that in 2009?
Keep it short and to the point. 1.1. What is the ratio of the Rent(as % of GDP) of Venezuela in 2007 to that in 2009?
Offer a very short reply. 2.24. What is the ratio of the Rent(as % of GDP) in Chad in 2007 to that in 2010?
Your answer should be compact. 0.77. What is the ratio of the Rent(as % of GDP) of Rwanda in 2007 to that in 2010?
Give a very brief answer. 0.04. What is the ratio of the Rent(as % of GDP) of South Africa in 2007 to that in 2010?
Give a very brief answer. 0.8. What is the ratio of the Rent(as % of GDP) in Venezuela in 2007 to that in 2010?
Provide a short and direct response. 1.5. What is the ratio of the Rent(as % of GDP) of Chad in 2007 to that in 2011?
Offer a very short reply. 0.65. What is the ratio of the Rent(as % of GDP) of Rwanda in 2007 to that in 2011?
Keep it short and to the point. 0.03. What is the ratio of the Rent(as % of GDP) in South Africa in 2007 to that in 2011?
Ensure brevity in your answer.  0.74. What is the ratio of the Rent(as % of GDP) of Venezuela in 2007 to that in 2011?
Make the answer very short. 0.84. What is the ratio of the Rent(as % of GDP) in Chad in 2007 to that in 2012?
Your answer should be very brief. 0.61. What is the ratio of the Rent(as % of GDP) in Rwanda in 2007 to that in 2012?
Your response must be concise. 0.11. What is the ratio of the Rent(as % of GDP) in South Africa in 2007 to that in 2012?
Provide a succinct answer. 0.81. What is the ratio of the Rent(as % of GDP) of Venezuela in 2007 to that in 2012?
Provide a succinct answer. 1.31. What is the ratio of the Rent(as % of GDP) of Chad in 2007 to that in 2013?
Provide a succinct answer. 0.79. What is the ratio of the Rent(as % of GDP) in Rwanda in 2007 to that in 2013?
Provide a succinct answer. 0.09. What is the ratio of the Rent(as % of GDP) of South Africa in 2007 to that in 2013?
Give a very brief answer. 0.81. What is the ratio of the Rent(as % of GDP) of Venezuela in 2007 to that in 2013?
Ensure brevity in your answer.  1.15. What is the ratio of the Rent(as % of GDP) in Chad in 2008 to that in 2009?
Your response must be concise. 0.72. What is the ratio of the Rent(as % of GDP) of Rwanda in 2008 to that in 2009?
Your response must be concise. 12.42. What is the ratio of the Rent(as % of GDP) of South Africa in 2008 to that in 2009?
Your answer should be compact. 1.49. What is the ratio of the Rent(as % of GDP) of Venezuela in 2008 to that in 2009?
Your answer should be very brief. 1.83. What is the ratio of the Rent(as % of GDP) in Chad in 2008 to that in 2010?
Your answer should be very brief. 0.6. What is the ratio of the Rent(as % of GDP) in Rwanda in 2008 to that in 2010?
Offer a very short reply. 0.43. What is the ratio of the Rent(as % of GDP) of South Africa in 2008 to that in 2010?
Offer a very short reply. 1.09. What is the ratio of the Rent(as % of GDP) of Venezuela in 2008 to that in 2010?
Your answer should be very brief. 1.23. What is the ratio of the Rent(as % of GDP) in Chad in 2008 to that in 2011?
Provide a succinct answer. 0.51. What is the ratio of the Rent(as % of GDP) in Rwanda in 2008 to that in 2011?
Give a very brief answer. 0.29. What is the ratio of the Rent(as % of GDP) of Venezuela in 2008 to that in 2011?
Your answer should be compact. 0.69. What is the ratio of the Rent(as % of GDP) of Chad in 2008 to that in 2012?
Offer a terse response. 0.47. What is the ratio of the Rent(as % of GDP) in Rwanda in 2008 to that in 2012?
Provide a succinct answer. 1.08. What is the ratio of the Rent(as % of GDP) in South Africa in 2008 to that in 2012?
Your answer should be very brief. 1.11. What is the ratio of the Rent(as % of GDP) in Venezuela in 2008 to that in 2012?
Provide a succinct answer. 1.07. What is the ratio of the Rent(as % of GDP) in Chad in 2008 to that in 2013?
Make the answer very short. 0.62. What is the ratio of the Rent(as % of GDP) of Rwanda in 2008 to that in 2013?
Provide a succinct answer. 0.91. What is the ratio of the Rent(as % of GDP) of South Africa in 2008 to that in 2013?
Make the answer very short. 1.11. What is the ratio of the Rent(as % of GDP) in Venezuela in 2008 to that in 2013?
Offer a very short reply. 0.94. What is the ratio of the Rent(as % of GDP) in Chad in 2009 to that in 2010?
Provide a succinct answer. 0.84. What is the ratio of the Rent(as % of GDP) of Rwanda in 2009 to that in 2010?
Your answer should be very brief. 0.03. What is the ratio of the Rent(as % of GDP) of South Africa in 2009 to that in 2010?
Offer a very short reply. 0.73. What is the ratio of the Rent(as % of GDP) of Venezuela in 2009 to that in 2010?
Offer a very short reply. 0.67. What is the ratio of the Rent(as % of GDP) in Chad in 2009 to that in 2011?
Offer a terse response. 0.7. What is the ratio of the Rent(as % of GDP) in Rwanda in 2009 to that in 2011?
Make the answer very short. 0.02. What is the ratio of the Rent(as % of GDP) of South Africa in 2009 to that in 2011?
Your answer should be compact. 0.67. What is the ratio of the Rent(as % of GDP) of Venezuela in 2009 to that in 2011?
Offer a terse response. 0.38. What is the ratio of the Rent(as % of GDP) in Chad in 2009 to that in 2012?
Give a very brief answer. 0.66. What is the ratio of the Rent(as % of GDP) in Rwanda in 2009 to that in 2012?
Offer a terse response. 0.09. What is the ratio of the Rent(as % of GDP) in South Africa in 2009 to that in 2012?
Keep it short and to the point. 0.74. What is the ratio of the Rent(as % of GDP) of Venezuela in 2009 to that in 2012?
Give a very brief answer. 0.59. What is the ratio of the Rent(as % of GDP) of Chad in 2009 to that in 2013?
Make the answer very short. 0.86. What is the ratio of the Rent(as % of GDP) in Rwanda in 2009 to that in 2013?
Offer a very short reply. 0.07. What is the ratio of the Rent(as % of GDP) of South Africa in 2009 to that in 2013?
Keep it short and to the point. 0.74. What is the ratio of the Rent(as % of GDP) in Venezuela in 2009 to that in 2013?
Keep it short and to the point. 0.51. What is the ratio of the Rent(as % of GDP) of Chad in 2010 to that in 2011?
Keep it short and to the point. 0.84. What is the ratio of the Rent(as % of GDP) in Rwanda in 2010 to that in 2011?
Keep it short and to the point. 0.67. What is the ratio of the Rent(as % of GDP) in South Africa in 2010 to that in 2011?
Your answer should be compact. 0.92. What is the ratio of the Rent(as % of GDP) of Venezuela in 2010 to that in 2011?
Your answer should be compact. 0.56. What is the ratio of the Rent(as % of GDP) in Chad in 2010 to that in 2012?
Provide a short and direct response. 0.79. What is the ratio of the Rent(as % of GDP) in Rwanda in 2010 to that in 2012?
Offer a terse response. 2.5. What is the ratio of the Rent(as % of GDP) in South Africa in 2010 to that in 2012?
Provide a short and direct response. 1.01. What is the ratio of the Rent(as % of GDP) in Venezuela in 2010 to that in 2012?
Provide a succinct answer. 0.87. What is the ratio of the Rent(as % of GDP) of Chad in 2010 to that in 2013?
Offer a terse response. 1.02. What is the ratio of the Rent(as % of GDP) of Rwanda in 2010 to that in 2013?
Offer a terse response. 2.11. What is the ratio of the Rent(as % of GDP) in South Africa in 2010 to that in 2013?
Make the answer very short. 1.01. What is the ratio of the Rent(as % of GDP) of Venezuela in 2010 to that in 2013?
Your response must be concise. 0.77. What is the ratio of the Rent(as % of GDP) in Chad in 2011 to that in 2012?
Make the answer very short. 0.94. What is the ratio of the Rent(as % of GDP) in Rwanda in 2011 to that in 2012?
Provide a succinct answer. 3.72. What is the ratio of the Rent(as % of GDP) in South Africa in 2011 to that in 2012?
Provide a short and direct response. 1.1. What is the ratio of the Rent(as % of GDP) of Venezuela in 2011 to that in 2012?
Your answer should be very brief. 1.56. What is the ratio of the Rent(as % of GDP) in Chad in 2011 to that in 2013?
Offer a terse response. 1.22. What is the ratio of the Rent(as % of GDP) in Rwanda in 2011 to that in 2013?
Keep it short and to the point. 3.13. What is the ratio of the Rent(as % of GDP) in South Africa in 2011 to that in 2013?
Provide a short and direct response. 1.1. What is the ratio of the Rent(as % of GDP) of Venezuela in 2011 to that in 2013?
Offer a terse response. 1.36. What is the ratio of the Rent(as % of GDP) in Chad in 2012 to that in 2013?
Provide a succinct answer. 1.3. What is the ratio of the Rent(as % of GDP) of Rwanda in 2012 to that in 2013?
Offer a terse response. 0.84. What is the ratio of the Rent(as % of GDP) in South Africa in 2012 to that in 2013?
Offer a very short reply. 1. What is the ratio of the Rent(as % of GDP) of Venezuela in 2012 to that in 2013?
Keep it short and to the point. 0.88. What is the difference between the highest and the second highest Rent(as % of GDP) of Chad?
Offer a terse response. 0. What is the difference between the highest and the second highest Rent(as % of GDP) in Rwanda?
Ensure brevity in your answer.  0.15. What is the difference between the highest and the second highest Rent(as % of GDP) in South Africa?
Provide a succinct answer. 0.01. What is the difference between the highest and the second highest Rent(as % of GDP) in Venezuela?
Provide a succinct answer. 0.24. What is the difference between the highest and the lowest Rent(as % of GDP) in Chad?
Give a very brief answer. 0.02. What is the difference between the highest and the lowest Rent(as % of GDP) in Rwanda?
Provide a short and direct response. 0.47. What is the difference between the highest and the lowest Rent(as % of GDP) in South Africa?
Give a very brief answer. 1.96. What is the difference between the highest and the lowest Rent(as % of GDP) in Venezuela?
Give a very brief answer. 0.94. 